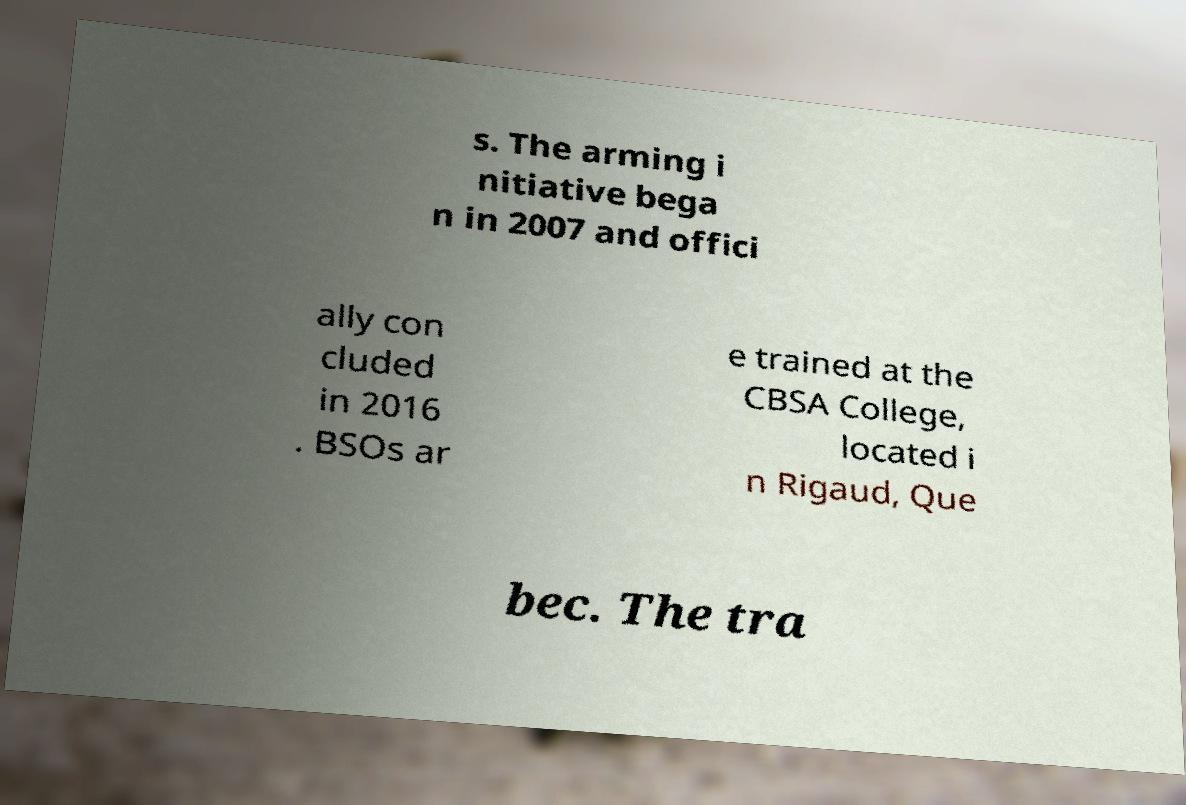Can you accurately transcribe the text from the provided image for me? s. The arming i nitiative bega n in 2007 and offici ally con cluded in 2016 . BSOs ar e trained at the CBSA College, located i n Rigaud, Que bec. The tra 